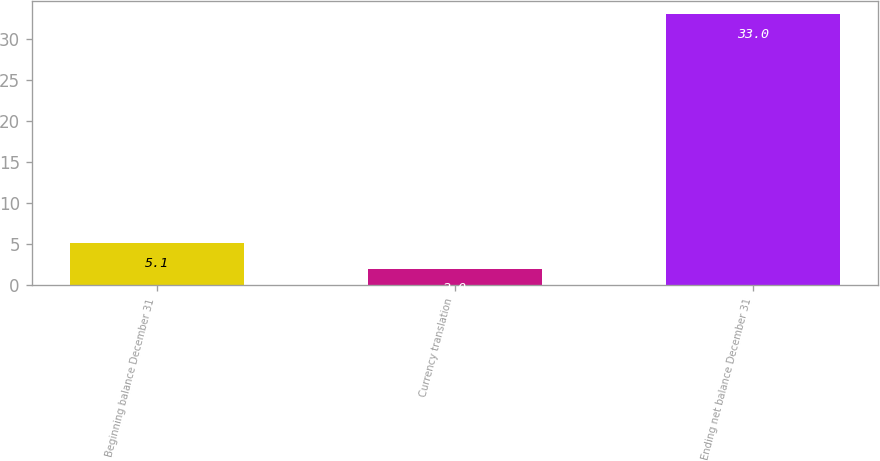<chart> <loc_0><loc_0><loc_500><loc_500><bar_chart><fcel>Beginning balance December 31<fcel>Currency translation<fcel>Ending net balance December 31<nl><fcel>5.1<fcel>2<fcel>33<nl></chart> 